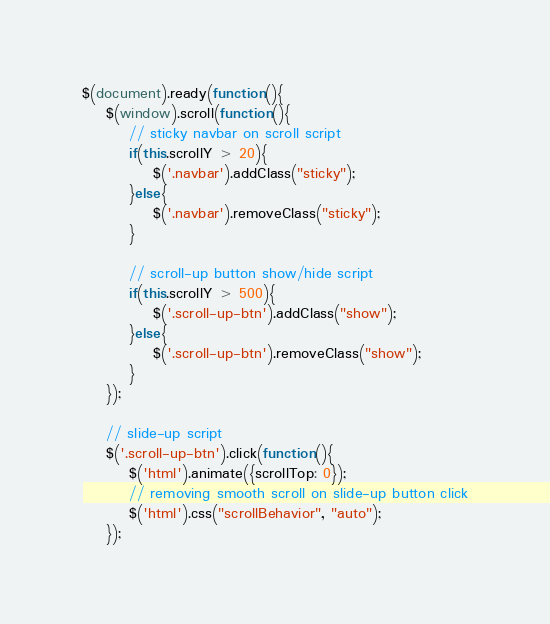Convert code to text. <code><loc_0><loc_0><loc_500><loc_500><_JavaScript_>$(document).ready(function(){
    $(window).scroll(function(){
        // sticky navbar on scroll script
        if(this.scrollY > 20){
            $('.navbar').addClass("sticky");
        }else{
            $('.navbar').removeClass("sticky");
        }
        
        // scroll-up button show/hide script
        if(this.scrollY > 500){
            $('.scroll-up-btn').addClass("show");
        }else{
            $('.scroll-up-btn').removeClass("show");
        }
    });

    // slide-up script
    $('.scroll-up-btn').click(function(){
        $('html').animate({scrollTop: 0});
        // removing smooth scroll on slide-up button click
        $('html').css("scrollBehavior", "auto");
    });
</code> 